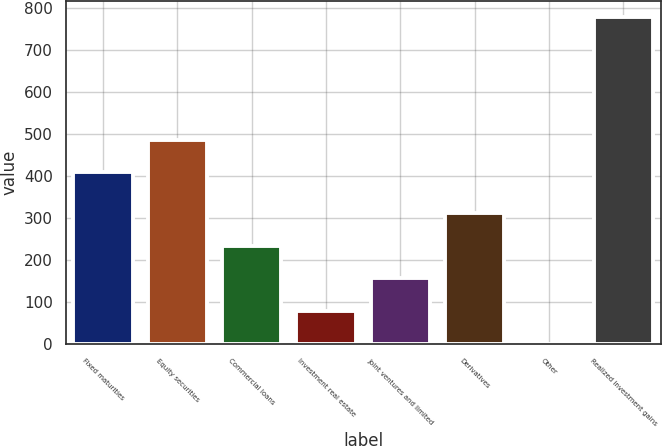<chart> <loc_0><loc_0><loc_500><loc_500><bar_chart><fcel>Fixed maturities<fcel>Equity securities<fcel>Commercial loans<fcel>Investment real estate<fcel>Joint ventures and limited<fcel>Derivatives<fcel>Other<fcel>Realized investment gains<nl><fcel>409<fcel>486.6<fcel>234.8<fcel>79.6<fcel>157.2<fcel>312.4<fcel>2<fcel>778<nl></chart> 